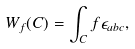Convert formula to latex. <formula><loc_0><loc_0><loc_500><loc_500>W _ { f } ( C ) = \int _ { C } f \epsilon _ { a b c } ,</formula> 